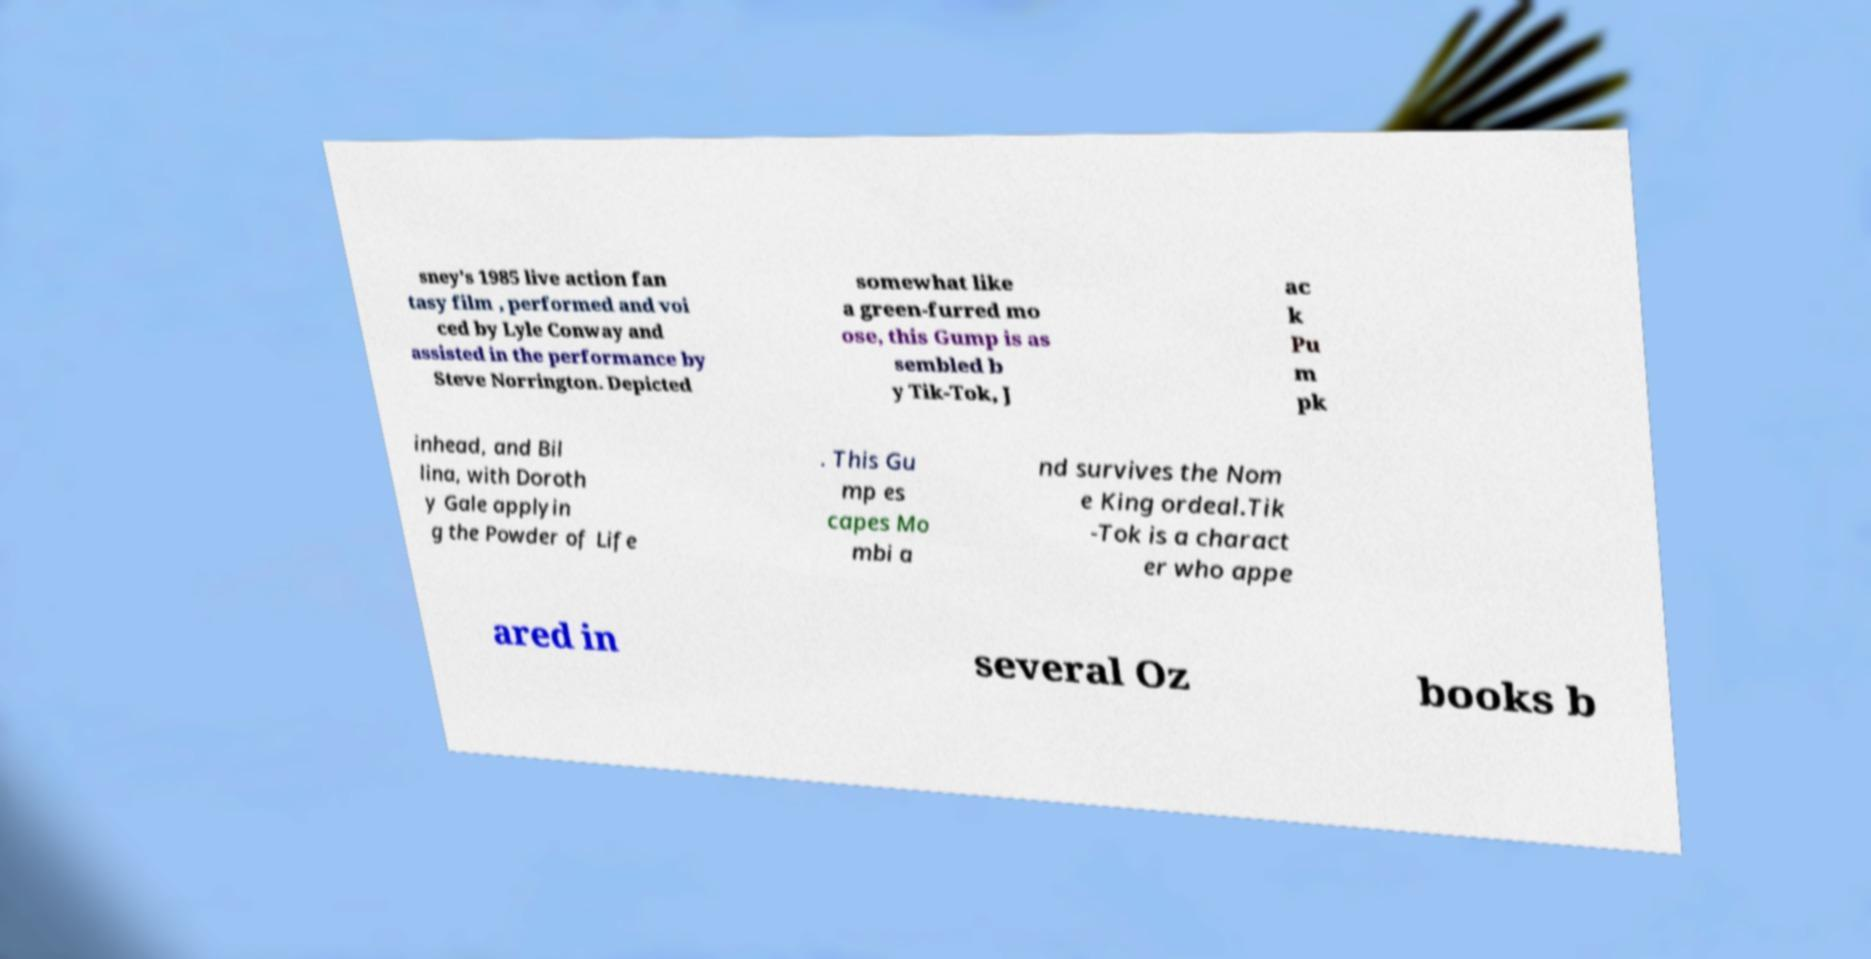Please identify and transcribe the text found in this image. sney's 1985 live action fan tasy film , performed and voi ced by Lyle Conway and assisted in the performance by Steve Norrington. Depicted somewhat like a green-furred mo ose, this Gump is as sembled b y Tik-Tok, J ac k Pu m pk inhead, and Bil lina, with Doroth y Gale applyin g the Powder of Life . This Gu mp es capes Mo mbi a nd survives the Nom e King ordeal.Tik -Tok is a charact er who appe ared in several Oz books b 